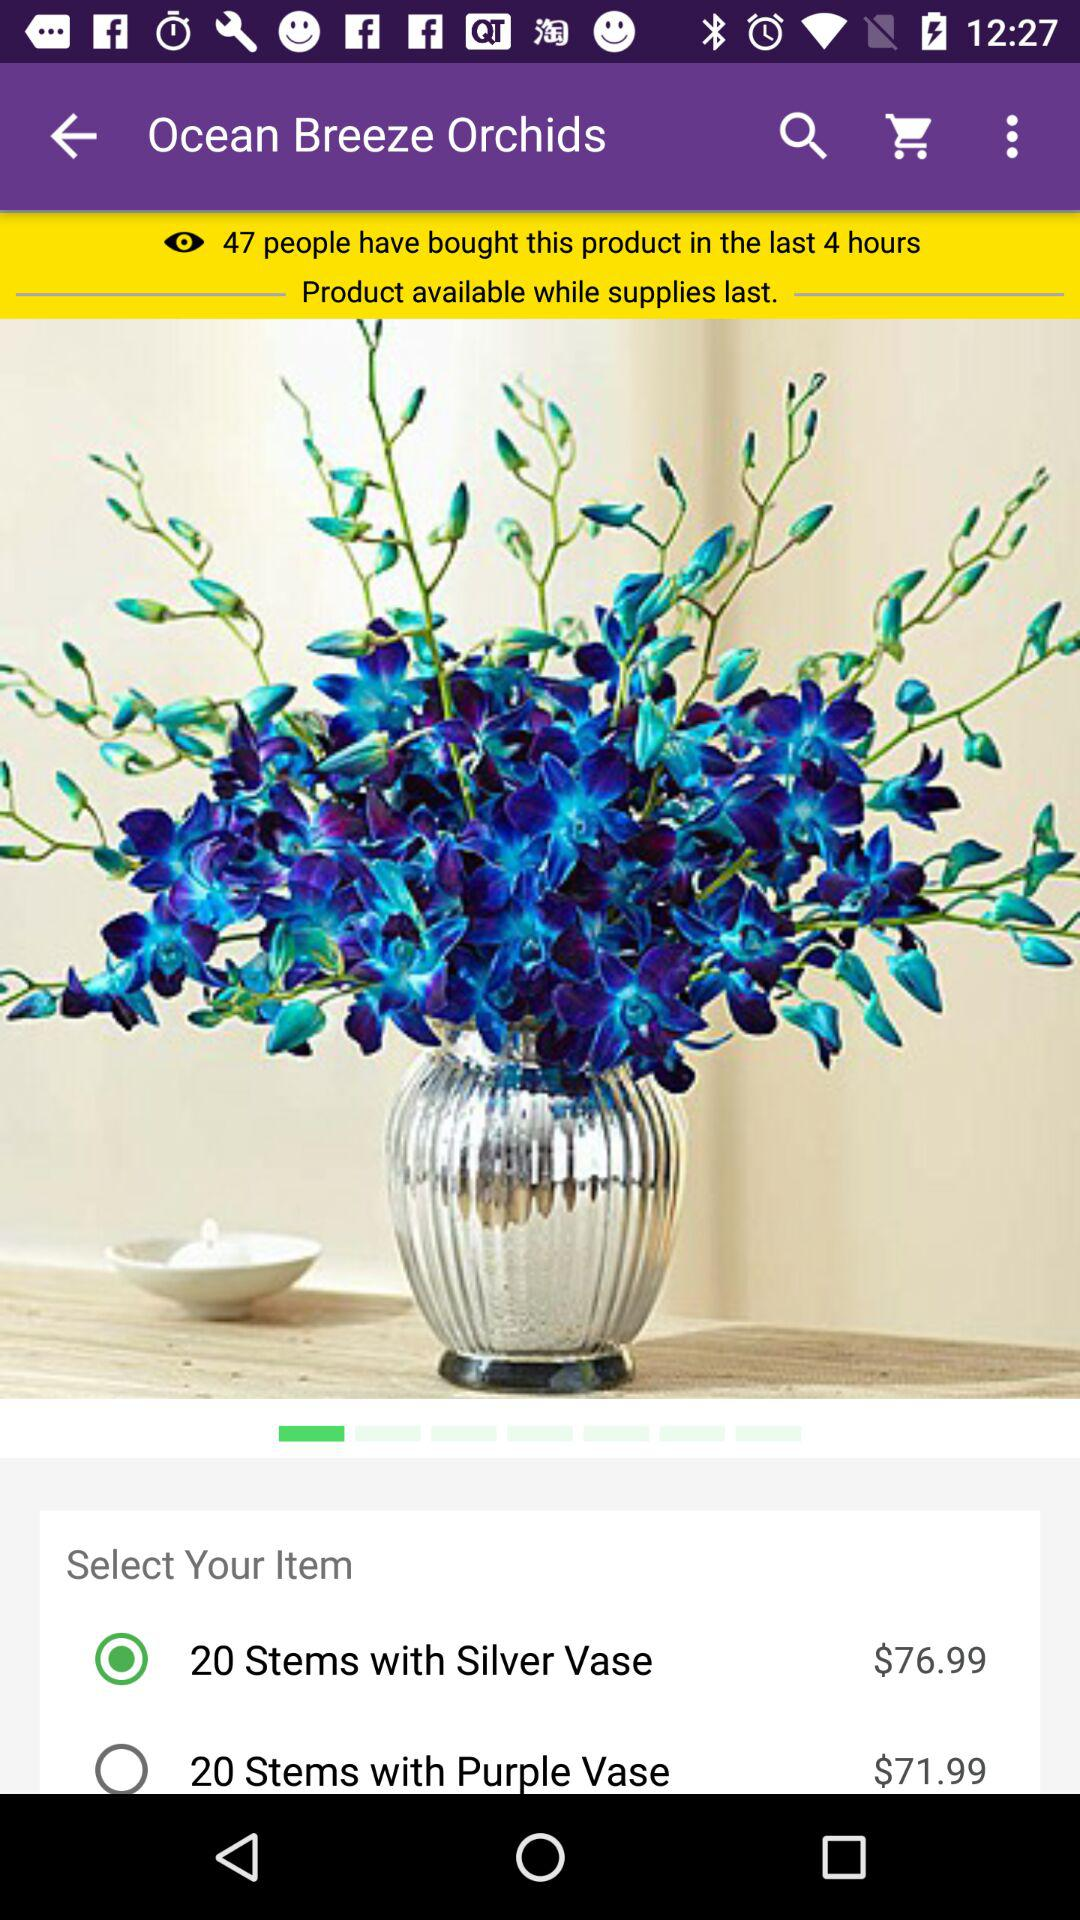How many people have bought this product in the last 4 hours?
Answer the question using a single word or phrase. 47 